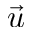Convert formula to latex. <formula><loc_0><loc_0><loc_500><loc_500>\vec { u }</formula> 